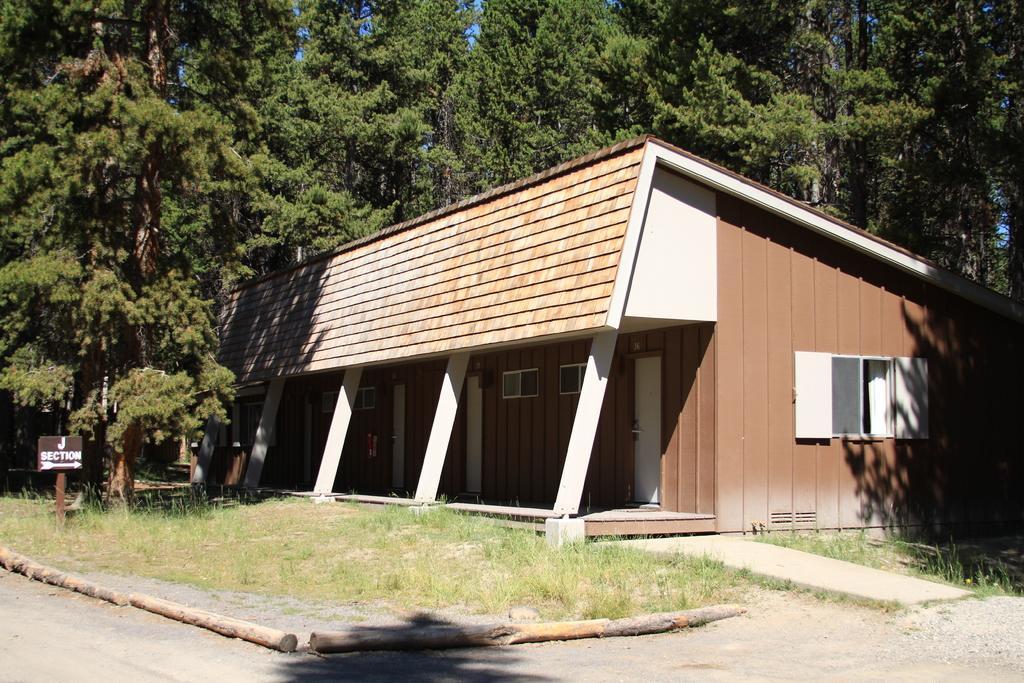Describe this image in one or two sentences. This is the picture of a building. In this image there is a building. At the back there are trees. On the left side of the image there is a board on the pole. At the bottom there are tree branches and there is grass. At the top there is sky. 